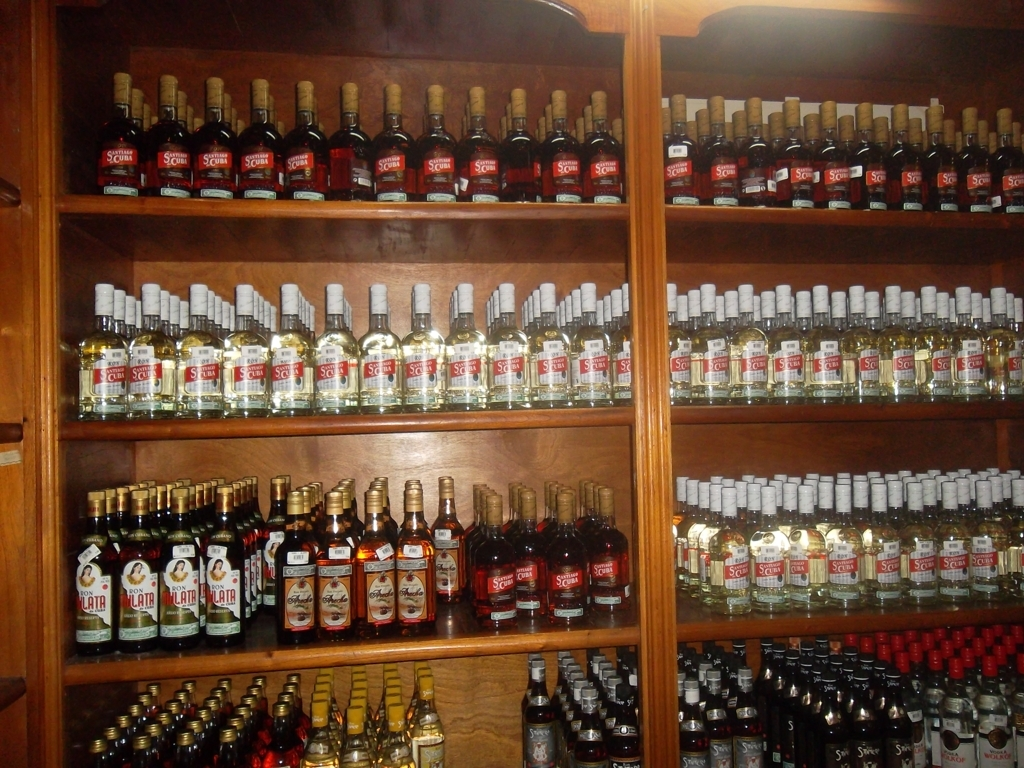Can you tell me about the types of beverages displayed here? Certainly! The image showcases a variety of distilled beverages, primarily what appears to be rum, based on the visible labels. There are both dark and light varieties, suggesting a range of flavors and potential uses in mixology. 